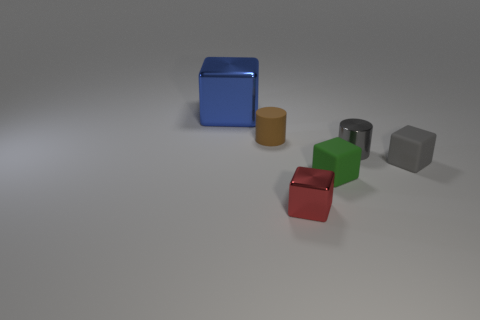Add 5 big blue things. How many big blue things exist? 6 Add 2 blue things. How many objects exist? 8 Subtract all red blocks. How many blocks are left? 3 Subtract all large shiny blocks. How many blocks are left? 3 Subtract 0 green cylinders. How many objects are left? 6 Subtract all cylinders. How many objects are left? 4 Subtract 1 cylinders. How many cylinders are left? 1 Subtract all red cylinders. Subtract all cyan spheres. How many cylinders are left? 2 Subtract all purple blocks. How many gray cylinders are left? 1 Subtract all cubes. Subtract all purple metal blocks. How many objects are left? 2 